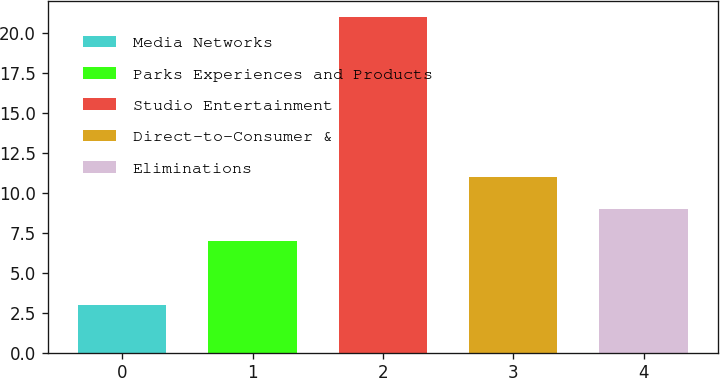<chart> <loc_0><loc_0><loc_500><loc_500><bar_chart><fcel>Media Networks<fcel>Parks Experiences and Products<fcel>Studio Entertainment<fcel>Direct-to-Consumer &<fcel>Eliminations<nl><fcel>3<fcel>7<fcel>21<fcel>11<fcel>9<nl></chart> 